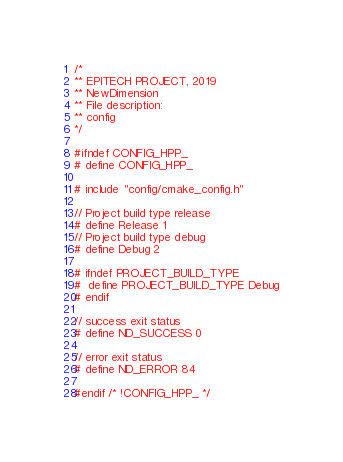Convert code to text. <code><loc_0><loc_0><loc_500><loc_500><_C++_>/*
** EPITECH PROJECT, 2019
** NewDimension
** File description:
** config
*/

#ifndef CONFIG_HPP_
# define CONFIG_HPP_

# include "config/cmake_config.h"

// Project build type release
# define Release 1
// Project build type debug
# define Debug 2

# ifndef PROJECT_BUILD_TYPE
#  define PROJECT_BUILD_TYPE Debug
# endif

// success exit status
# define ND_SUCCESS 0

// error exit status
# define ND_ERROR 84

#endif /* !CONFIG_HPP_ */
</code> 